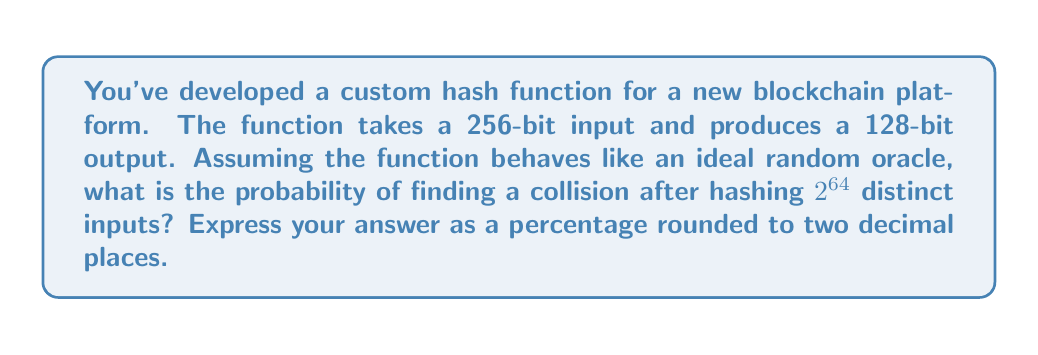Give your solution to this math problem. To evaluate the collision resistance of this custom hash function, we'll use the birthday paradox approach:

1) The output space of the hash function is 128 bits, so there are $2^{128}$ possible outputs.

2) We're hashing $2^{64}$ distinct inputs.

3) The probability of not finding a collision after $n$ hashes is approximately:

   $$P(\text{no collision}) \approx e^{-\frac{n^2}{2m}}$$

   Where $n$ is the number of hashes and $m$ is the size of the output space.

4) In this case, $n = 2^{64}$ and $m = 2^{128}$:

   $$P(\text{no collision}) \approx e^{-\frac{(2^{64})^2}{2(2^{128})}} = e^{-\frac{2^{128}}{2^{129}}} = e^{-0.5}$$

5) The probability of finding a collision is:

   $$P(\text{collision}) = 1 - P(\text{no collision}) \approx 1 - e^{-0.5}$$

6) Calculate this value:

   $$1 - e^{-0.5} \approx 0.3934693402873666$$

7) Convert to a percentage and round to two decimal places:

   $$0.3934693402873666 * 100 \approx 39.35\%$$
Answer: 39.35% 